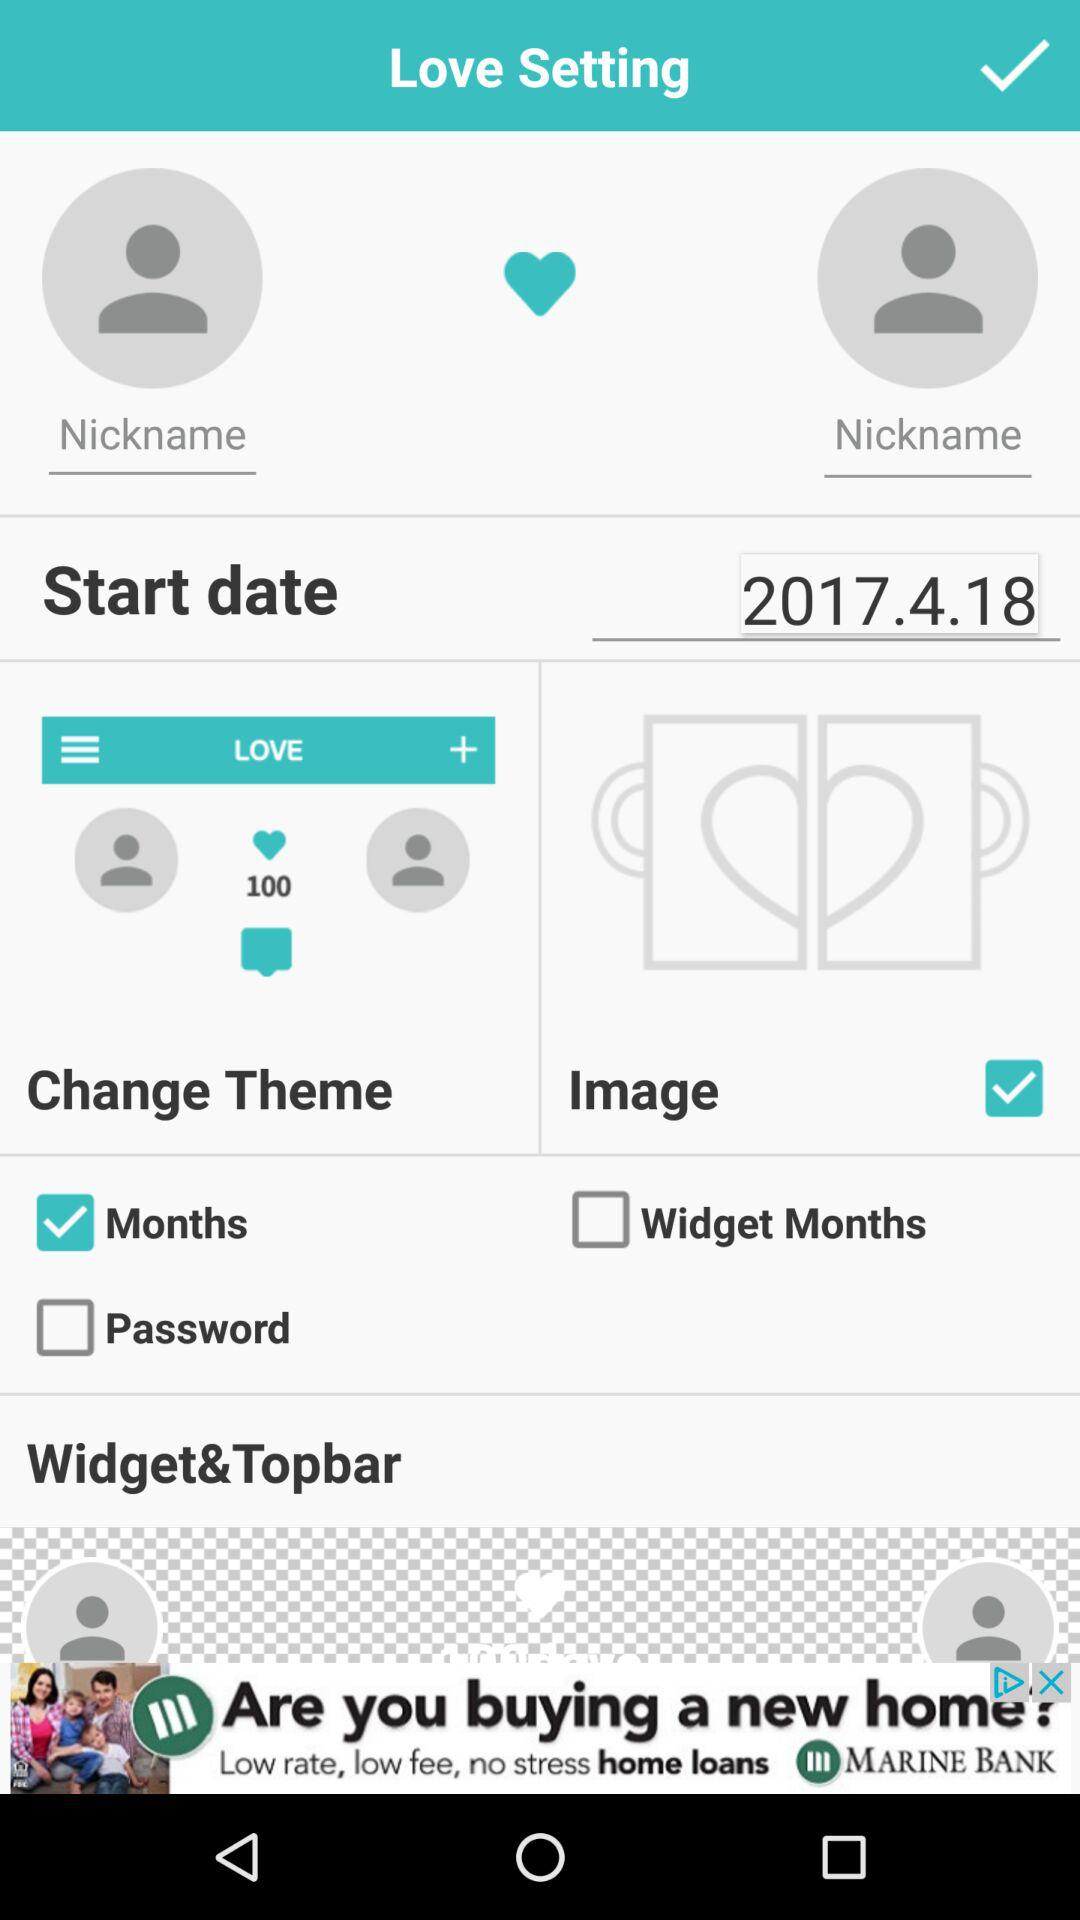What is the status of the "Months"? The status is "on". 